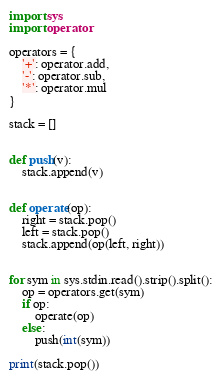<code> <loc_0><loc_0><loc_500><loc_500><_Python_>import sys
import operator

operators = {
    '+': operator.add,
    '-': operator.sub,
    '*': operator.mul
}

stack = []


def push(v):
    stack.append(v)


def operate(op):
    right = stack.pop()
    left = stack.pop()
    stack.append(op(left, right))


for sym in sys.stdin.read().strip().split():
    op = operators.get(sym)
    if op:
        operate(op)
    else:
        push(int(sym))

print(stack.pop())

</code> 